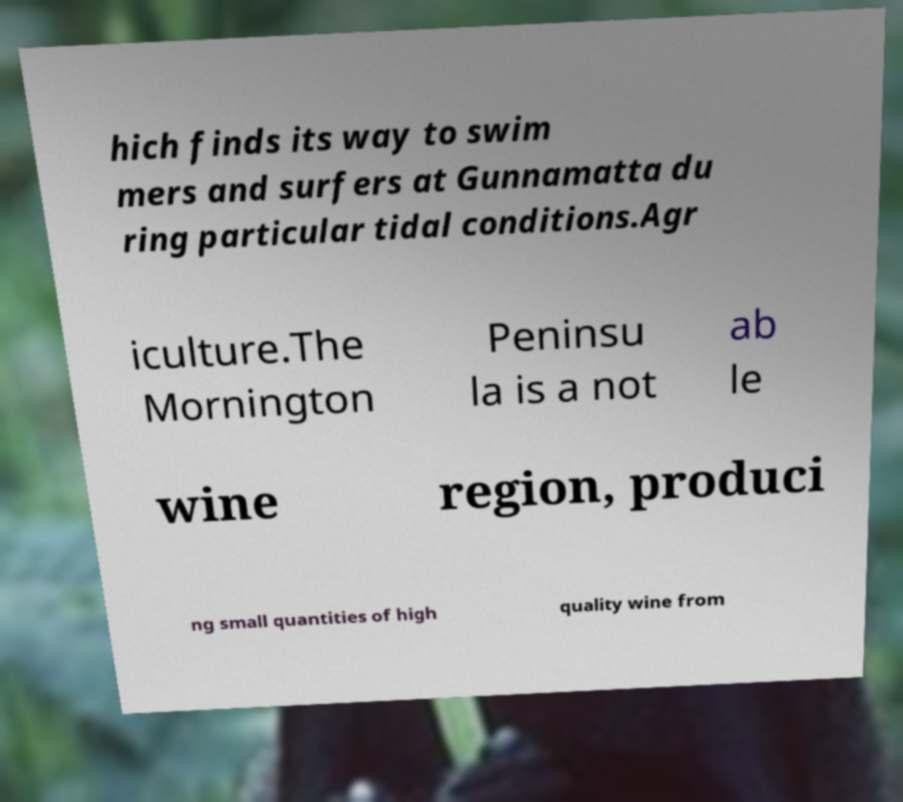Can you read and provide the text displayed in the image?This photo seems to have some interesting text. Can you extract and type it out for me? hich finds its way to swim mers and surfers at Gunnamatta du ring particular tidal conditions.Agr iculture.The Mornington Peninsu la is a not ab le wine region, produci ng small quantities of high quality wine from 